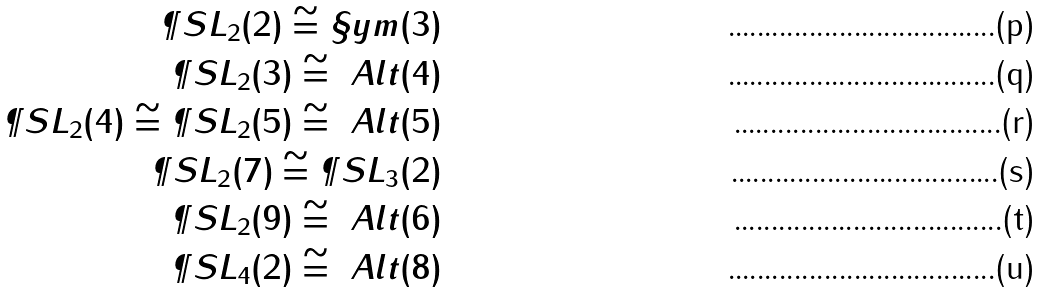Convert formula to latex. <formula><loc_0><loc_0><loc_500><loc_500>\P S L _ { 2 } ( 2 ) \cong \S y m ( 3 ) \\ \P S L _ { 2 } ( 3 ) \cong \ A l t ( 4 ) \\ \P S L _ { 2 } ( 4 ) \cong \P S L _ { 2 } ( 5 ) \cong \ A l t ( 5 ) \\ \P S L _ { 2 } ( 7 ) \cong \P S L _ { 3 } ( 2 ) \\ \P S L _ { 2 } ( 9 ) \cong \ A l t ( 6 ) \\ \P S L _ { 4 } ( 2 ) \cong \ A l t ( 8 )</formula> 